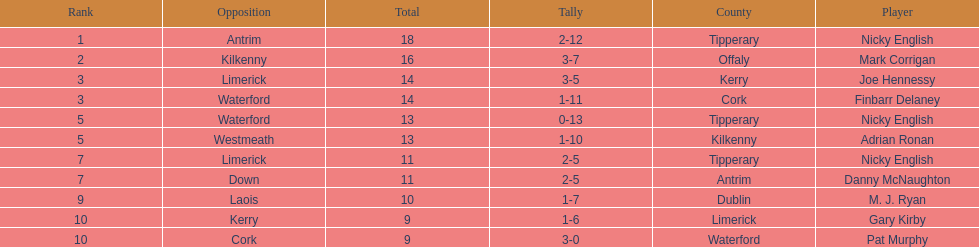What was the average of the totals of nicky english and mark corrigan? 17. Could you parse the entire table as a dict? {'header': ['Rank', 'Opposition', 'Total', 'Tally', 'County', 'Player'], 'rows': [['1', 'Antrim', '18', '2-12', 'Tipperary', 'Nicky English'], ['2', 'Kilkenny', '16', '3-7', 'Offaly', 'Mark Corrigan'], ['3', 'Limerick', '14', '3-5', 'Kerry', 'Joe Hennessy'], ['3', 'Waterford', '14', '1-11', 'Cork', 'Finbarr Delaney'], ['5', 'Waterford', '13', '0-13', 'Tipperary', 'Nicky English'], ['5', 'Westmeath', '13', '1-10', 'Kilkenny', 'Adrian Ronan'], ['7', 'Limerick', '11', '2-5', 'Tipperary', 'Nicky English'], ['7', 'Down', '11', '2-5', 'Antrim', 'Danny McNaughton'], ['9', 'Laois', '10', '1-7', 'Dublin', 'M. J. Ryan'], ['10', 'Kerry', '9', '1-6', 'Limerick', 'Gary Kirby'], ['10', 'Cork', '9', '3-0', 'Waterford', 'Pat Murphy']]} 